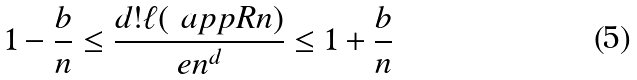Convert formula to latex. <formula><loc_0><loc_0><loc_500><loc_500>1 - \frac { b } { n } \leq \frac { d ! \ell ( \ a p p R n ) } { e n ^ { d } } \leq 1 + \frac { b } { n }</formula> 